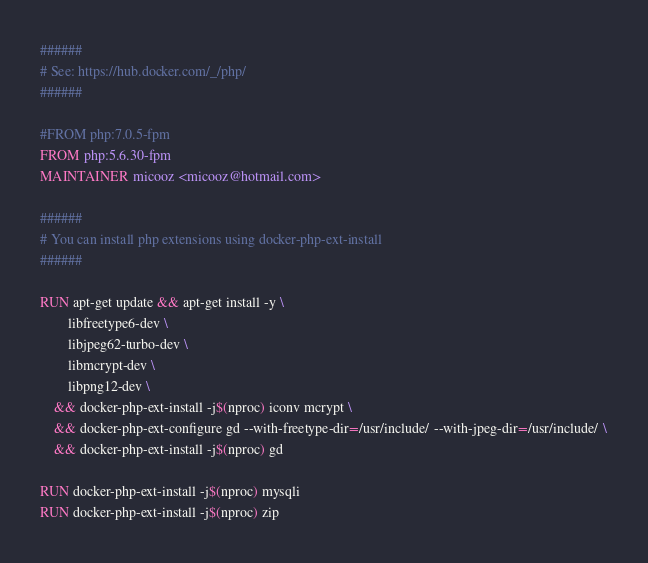Convert code to text. <code><loc_0><loc_0><loc_500><loc_500><_Dockerfile_>######
# See: https://hub.docker.com/_/php/
######

#FROM php:7.0.5-fpm
FROM php:5.6.30-fpm
MAINTAINER micooz <micooz@hotmail.com>

######
# You can install php extensions using docker-php-ext-install
######

RUN apt-get update && apt-get install -y \
        libfreetype6-dev \
        libjpeg62-turbo-dev \
        libmcrypt-dev \
        libpng12-dev \
    && docker-php-ext-install -j$(nproc) iconv mcrypt \
    && docker-php-ext-configure gd --with-freetype-dir=/usr/include/ --with-jpeg-dir=/usr/include/ \
    && docker-php-ext-install -j$(nproc) gd 

RUN docker-php-ext-install -j$(nproc) mysqli
RUN docker-php-ext-install -j$(nproc) zip
</code> 